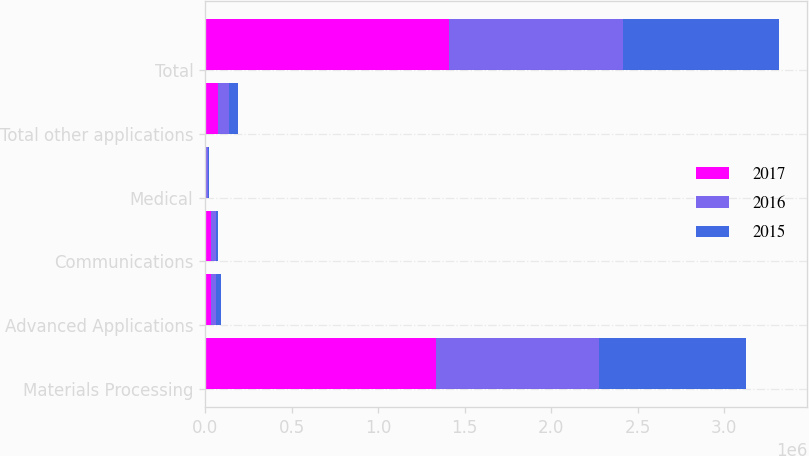Convert chart to OTSL. <chart><loc_0><loc_0><loc_500><loc_500><stacked_bar_chart><ecel><fcel>Materials Processing<fcel>Advanced Applications<fcel>Communications<fcel>Medical<fcel>Total other applications<fcel>Total<nl><fcel>2017<fcel>1.33261e+06<fcel>36836<fcel>32023<fcel>7423<fcel>76282<fcel>1.40889e+06<nl><fcel>2016<fcel>942119<fcel>28166<fcel>28823<fcel>7065<fcel>64054<fcel>1.00617e+06<nl><fcel>2015<fcel>849335<fcel>28866<fcel>14399<fcel>8665<fcel>51930<fcel>901265<nl></chart> 